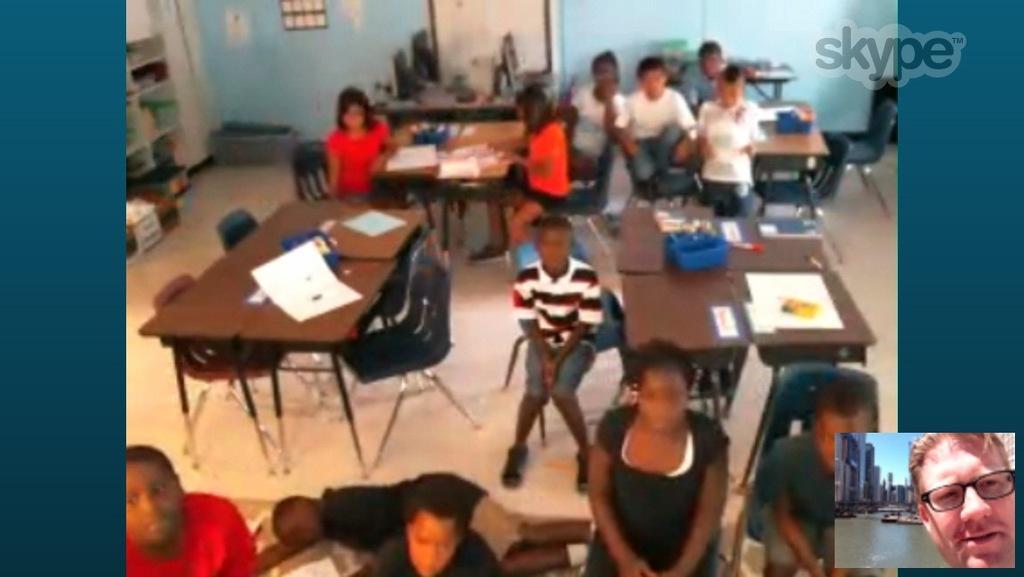Please provide a concise description of this image. In this image there are group of people sitting on the chair. On the table there is a paper and some material. 